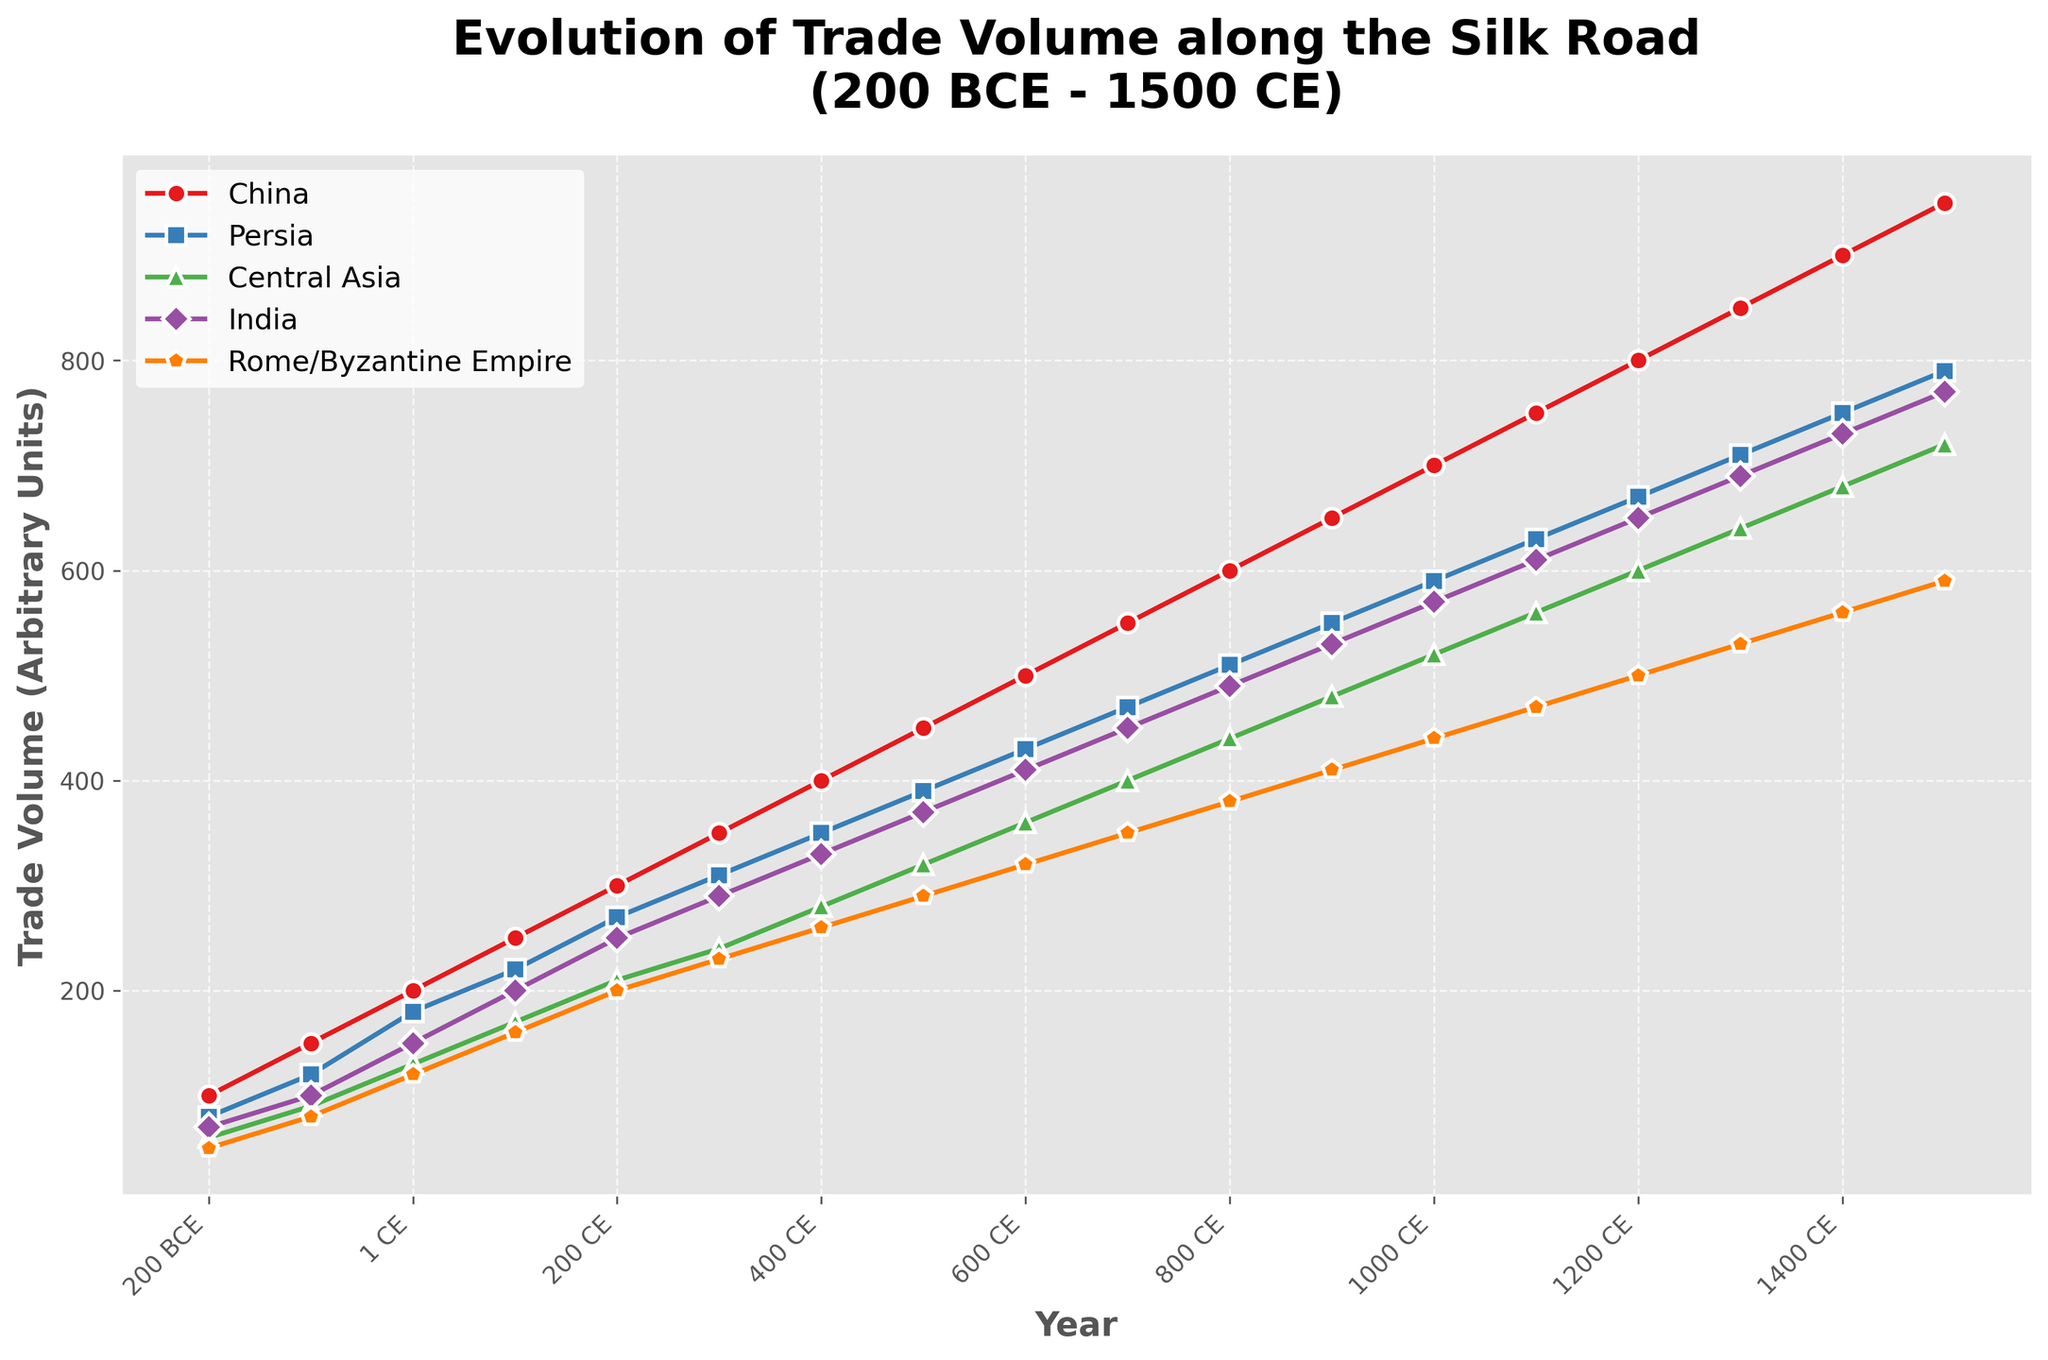How did the trade volume of China compare between 200 BCE and 1500 CE? Look at the data points for China in 200 BCE and in 1500 CE. In 200 BCE, the trade volume is 100, and in 1500 CE, it rises to 950. Therefore, the trade volume of China increased significantly over this period.
Answer: Increased significantly Which region experienced the largest growth in trade volume from 200 BCE to 1500 CE? Calculate the difference in trade volumes for each region between 200 BCE and 1500 CE: China (950 - 100 = 850), Persia (790 - 80 = 710), Central Asia (720 - 60 = 660), India (770 - 70 = 700), and Rome/Byzantine Empire (590 - 50 = 540). China has the largest growth with 850 units.
Answer: China Between which two consecutive centuries did India's trade volume increase the most? Compare the trade volume increases between consecutive centuries for India. Max increase occurs between 200 CE (250) and 300 CE (290), which is 40 units. This is the highest incremental change.
Answer: 200 CE and 300 CE Which region had the smallest trade volume in 100 CE? Refer to the trade volumes for the year 100 CE: China (250), Persia (220), Central Asia (170), India (200), Rome/Byzantine Empire (160). The smallest trade volume is in Rome/Byzantine Empire.
Answer: Rome/Byzantine Empire What is the average trade volume of Persia from 1 CE to 500 CE? Calculate the average for Persia's trade volumes for the years 1 CE, 100 CE, 200 CE, 300 CE, 400 CE, and 500 CE. Sum the figures (180 + 220 + 270 + 310 + 350 + 390) = 1720. The number of data points is 6, so the average is 1720 / 6 ≈ 286.7.
Answer: 286.7 How does the trade volume of Central Asia compare to India in 1200 CE? Look at the trade volumes for Central Asia and India in 1200 CE. Central Asia has 600 and India has 650. Central Asia has a smaller trade volume compared to India.
Answer: Smaller During which century did the trade volume in the Rome/Byzantine Empire first surpass 500 units? Identify the data point where the trade volume of the Rome/Byzantine Empire surpasses 500 for the first time. In 1500 CE, the trade volume is 590, which is the first instance where it crosses 500 units.
Answer: 1500 CE By how much did the trade volume of Persia increase from 600 CE to 900 CE? Subtract the trade volume of Persia in 600 CE from its trade volume in 900 CE. In 600 CE, it's 430, and in 900 CE, it's 550. The increase is 550 - 430 = 120.
Answer: 120 units What were the three highest trade volumes recorded for Rome/Byzantine Empire before 1000 CE? Identify the trade volumes for Rome/Byzantine Empire before 1000 CE: 50, 80, 120, 160, 200, 230, 260, 290, 320, 350, 380, and 410. The three highest are 380, 410, and 350.
Answer: 410, 380, 350 Which region showed a consistent increase in trade volume through the entire recorded period? Compare the trade volumes of all regions over the entire period from 200 BCE to 1500 CE. All regions—China, Persia, Central Asia, India, and Rome/Byzantine Empire—show consistent increases without any decrease at any point.
Answer: All regions 